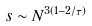Convert formula to latex. <formula><loc_0><loc_0><loc_500><loc_500>s \sim N ^ { 3 ( 1 - 2 / \tau ) }</formula> 